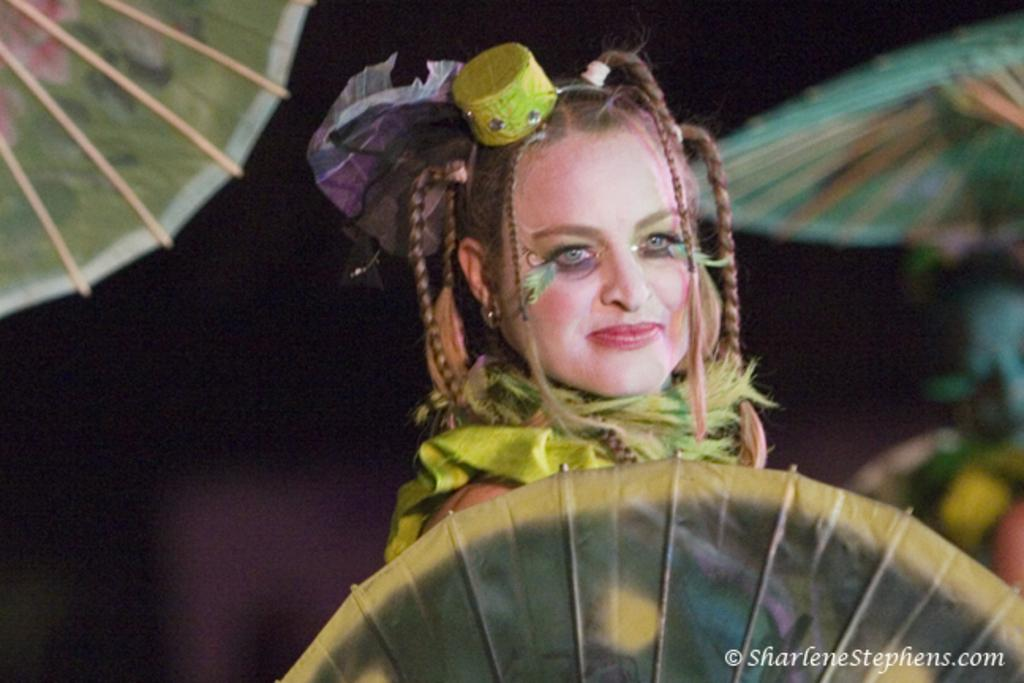Who is present in the image? There is a woman in the image. What is the woman wearing? The woman is wearing a costume. What objects are surrounding the woman? There are umbrellas around the woman. What type of thumb can be seen on the woman's costume in the image? There is no thumb present on the woman's costume in the image. 